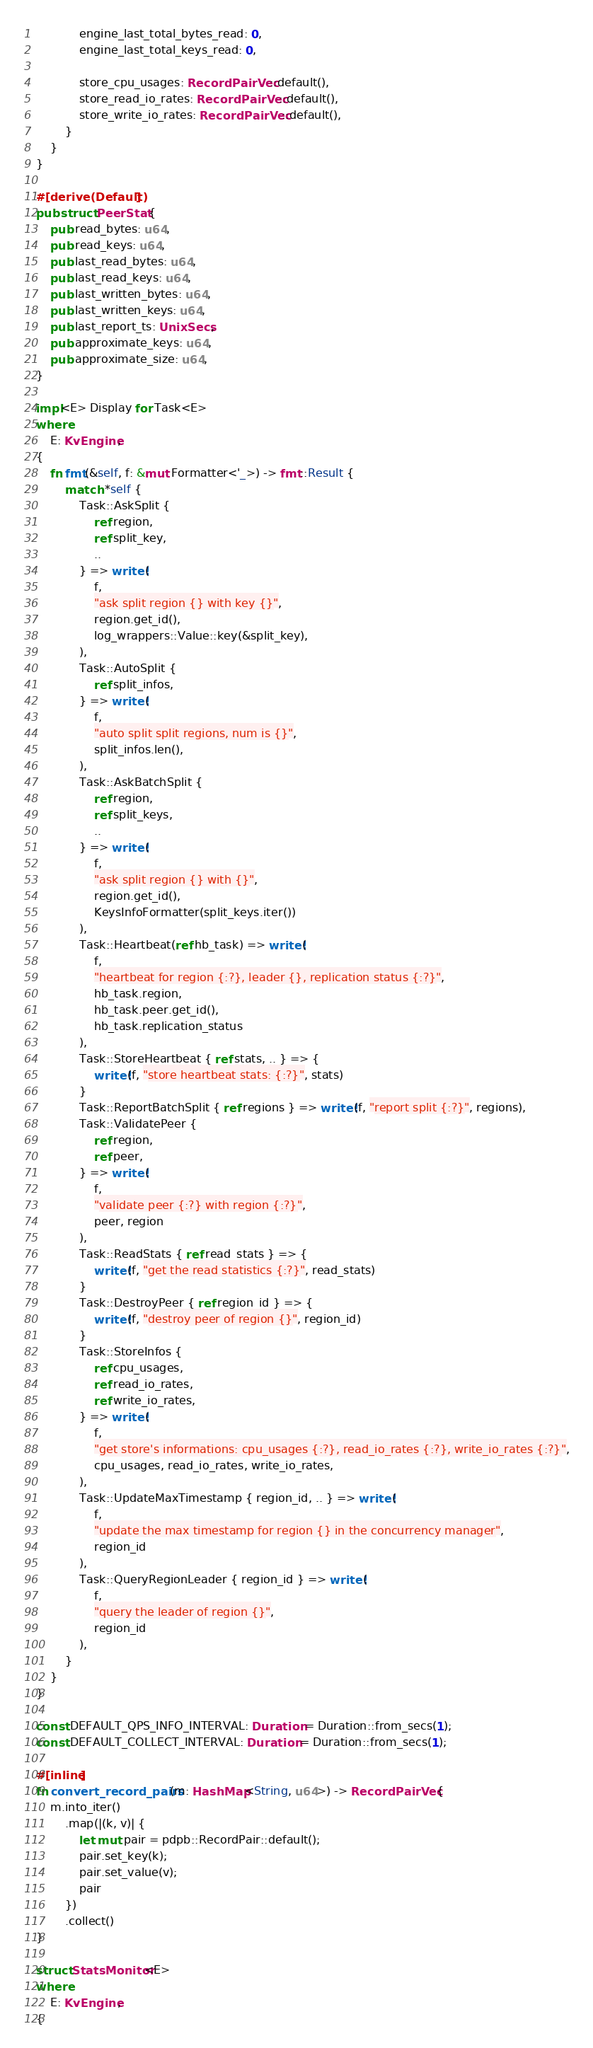<code> <loc_0><loc_0><loc_500><loc_500><_Rust_>            engine_last_total_bytes_read: 0,
            engine_last_total_keys_read: 0,

            store_cpu_usages: RecordPairVec::default(),
            store_read_io_rates: RecordPairVec::default(),
            store_write_io_rates: RecordPairVec::default(),
        }
    }
}

#[derive(Default)]
pub struct PeerStat {
    pub read_bytes: u64,
    pub read_keys: u64,
    pub last_read_bytes: u64,
    pub last_read_keys: u64,
    pub last_written_bytes: u64,
    pub last_written_keys: u64,
    pub last_report_ts: UnixSecs,
    pub approximate_keys: u64,
    pub approximate_size: u64,
}

impl<E> Display for Task<E>
where
    E: KvEngine,
{
    fn fmt(&self, f: &mut Formatter<'_>) -> fmt::Result {
        match *self {
            Task::AskSplit {
                ref region,
                ref split_key,
                ..
            } => write!(
                f,
                "ask split region {} with key {}",
                region.get_id(),
                log_wrappers::Value::key(&split_key),
            ),
            Task::AutoSplit {
                ref split_infos,
            } => write!(
                f,
                "auto split split regions, num is {}",
                split_infos.len(),
            ),
            Task::AskBatchSplit {
                ref region,
                ref split_keys,
                ..
            } => write!(
                f,
                "ask split region {} with {}",
                region.get_id(),
                KeysInfoFormatter(split_keys.iter())
            ),
            Task::Heartbeat(ref hb_task) => write!(
                f,
                "heartbeat for region {:?}, leader {}, replication status {:?}",
                hb_task.region,
                hb_task.peer.get_id(),
                hb_task.replication_status
            ),
            Task::StoreHeartbeat { ref stats, .. } => {
                write!(f, "store heartbeat stats: {:?}", stats)
            }
            Task::ReportBatchSplit { ref regions } => write!(f, "report split {:?}", regions),
            Task::ValidatePeer {
                ref region,
                ref peer,
            } => write!(
                f,
                "validate peer {:?} with region {:?}",
                peer, region
            ),
            Task::ReadStats { ref read_stats } => {
                write!(f, "get the read statistics {:?}", read_stats)
            }
            Task::DestroyPeer { ref region_id } => {
                write!(f, "destroy peer of region {}", region_id)
            }
            Task::StoreInfos {
                ref cpu_usages,
                ref read_io_rates,
                ref write_io_rates,
            } => write!(
                f,
                "get store's informations: cpu_usages {:?}, read_io_rates {:?}, write_io_rates {:?}",
                cpu_usages, read_io_rates, write_io_rates,
            ),
            Task::UpdateMaxTimestamp { region_id, .. } => write!(
                f,
                "update the max timestamp for region {} in the concurrency manager",
                region_id
            ),
            Task::QueryRegionLeader { region_id } => write!(
                f,
                "query the leader of region {}",
                region_id
            ),
        }
    }
}

const DEFAULT_QPS_INFO_INTERVAL: Duration = Duration::from_secs(1);
const DEFAULT_COLLECT_INTERVAL: Duration = Duration::from_secs(1);

#[inline]
fn convert_record_pairs(m: HashMap<String, u64>) -> RecordPairVec {
    m.into_iter()
        .map(|(k, v)| {
            let mut pair = pdpb::RecordPair::default();
            pair.set_key(k);
            pair.set_value(v);
            pair
        })
        .collect()
}

struct StatsMonitor<E>
where
    E: KvEngine,
{</code> 